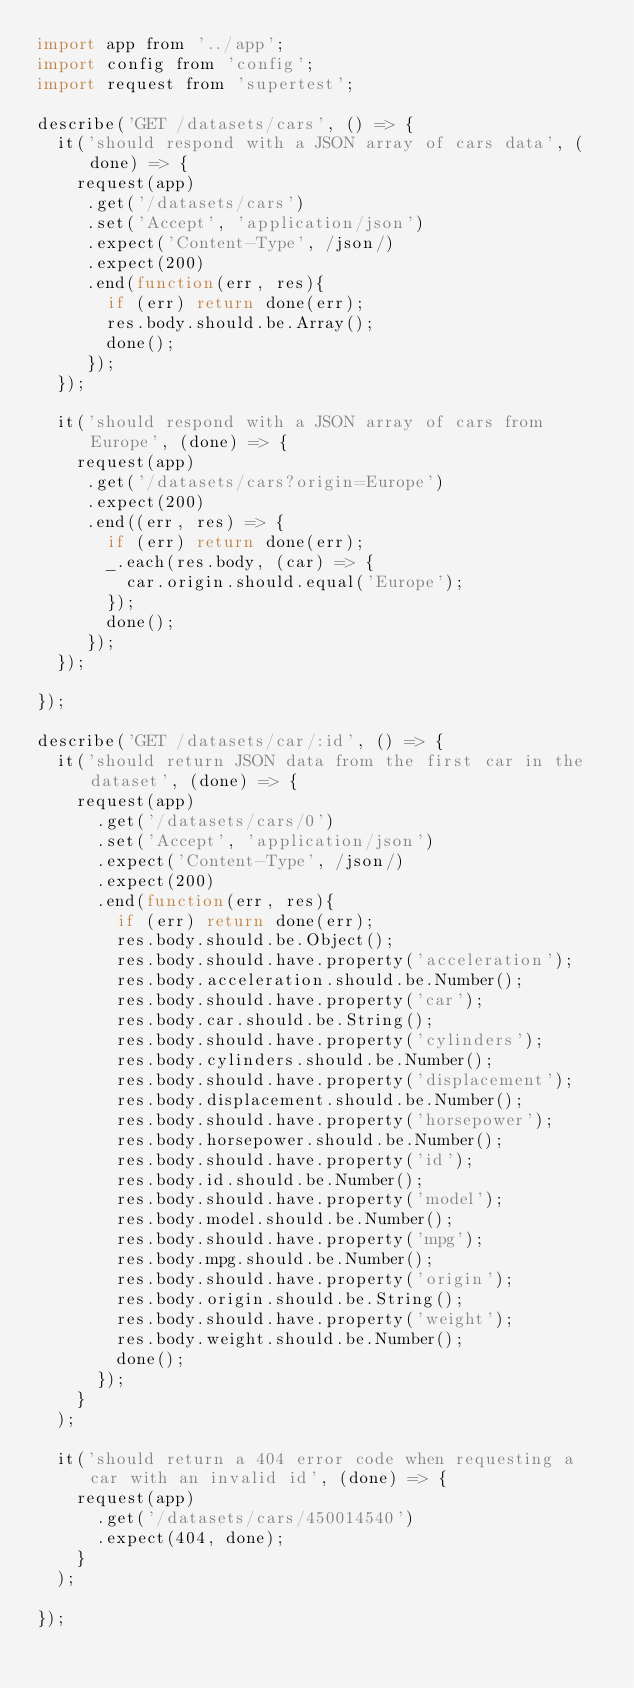Convert code to text. <code><loc_0><loc_0><loc_500><loc_500><_JavaScript_>import app from '../app';
import config from 'config';
import request from 'supertest';

describe('GET /datasets/cars', () => {
  it('should respond with a JSON array of cars data', (done) => {
    request(app)
     .get('/datasets/cars')
     .set('Accept', 'application/json')
     .expect('Content-Type', /json/)
     .expect(200)
     .end(function(err, res){
       if (err) return done(err);
       res.body.should.be.Array();
       done();
     });
  });

  it('should respond with a JSON array of cars from Europe', (done) => {
    request(app)
     .get('/datasets/cars?origin=Europe')
     .expect(200)
     .end((err, res) => {
       if (err) return done(err);
       _.each(res.body, (car) => {
         car.origin.should.equal('Europe');
       });
       done();
     });
  });

});

describe('GET /datasets/car/:id', () => {
  it('should return JSON data from the first car in the dataset', (done) => {
    request(app)
      .get('/datasets/cars/0')
      .set('Accept', 'application/json')
      .expect('Content-Type', /json/)
      .expect(200)
      .end(function(err, res){
        if (err) return done(err);
        res.body.should.be.Object();
        res.body.should.have.property('acceleration');
        res.body.acceleration.should.be.Number();
        res.body.should.have.property('car');
        res.body.car.should.be.String();
        res.body.should.have.property('cylinders');
        res.body.cylinders.should.be.Number();
        res.body.should.have.property('displacement');
        res.body.displacement.should.be.Number();
        res.body.should.have.property('horsepower');
        res.body.horsepower.should.be.Number();
        res.body.should.have.property('id');
        res.body.id.should.be.Number();
        res.body.should.have.property('model');
        res.body.model.should.be.Number();
        res.body.should.have.property('mpg');
        res.body.mpg.should.be.Number();
        res.body.should.have.property('origin');
        res.body.origin.should.be.String();
        res.body.should.have.property('weight');
        res.body.weight.should.be.Number();
        done();
      });
    }
  );

  it('should return a 404 error code when requesting a car with an invalid id', (done) => {
    request(app)
      .get('/datasets/cars/450014540')
      .expect(404, done);
    }
  );

});
</code> 